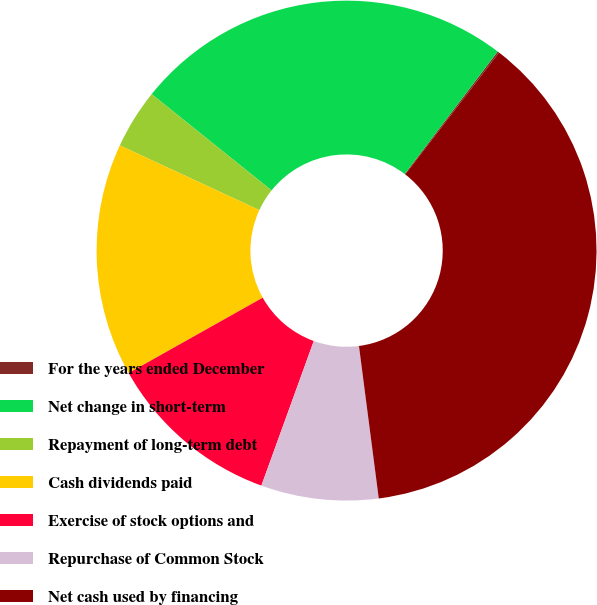Convert chart to OTSL. <chart><loc_0><loc_0><loc_500><loc_500><pie_chart><fcel>For the years ended December<fcel>Net change in short-term<fcel>Repayment of long-term debt<fcel>Cash dividends paid<fcel>Exercise of stock options and<fcel>Repurchase of Common Stock<fcel>Net cash used by financing<nl><fcel>0.11%<fcel>24.57%<fcel>3.85%<fcel>15.06%<fcel>11.32%<fcel>7.59%<fcel>37.5%<nl></chart> 